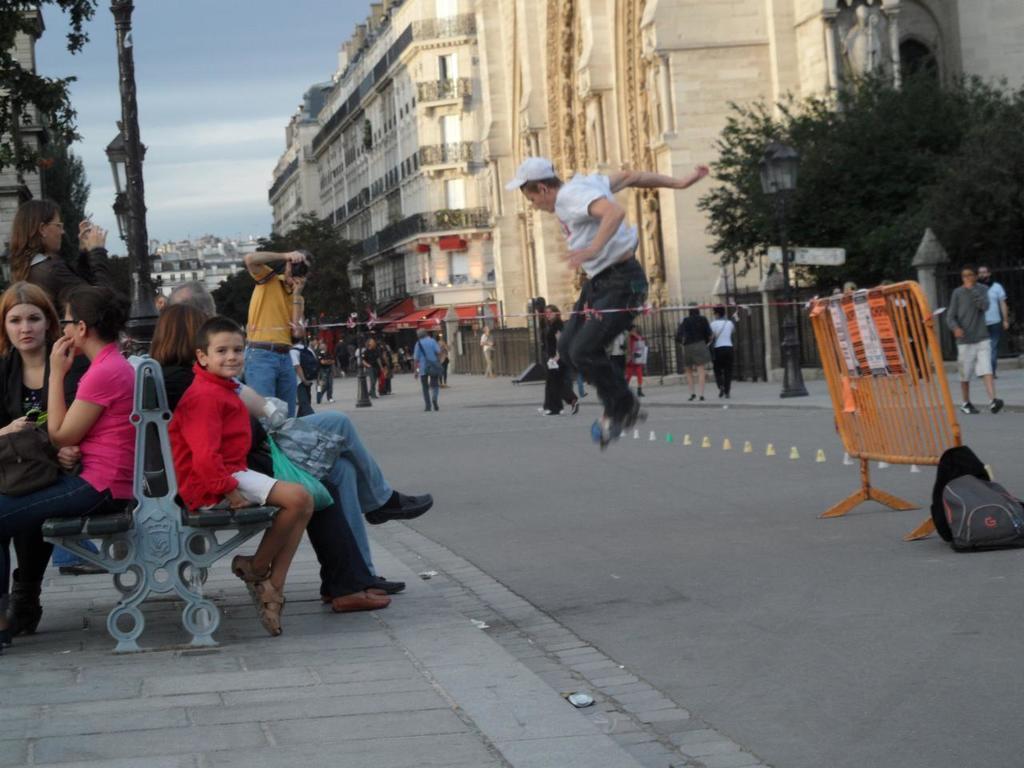Could you give a brief overview of what you see in this image? In this image we can see a few people, among them, some people are sitting on the bench, there are some buildings, trees, fence, poles, lights, bag and a railing, in the background, we can see the sky with clouds. 